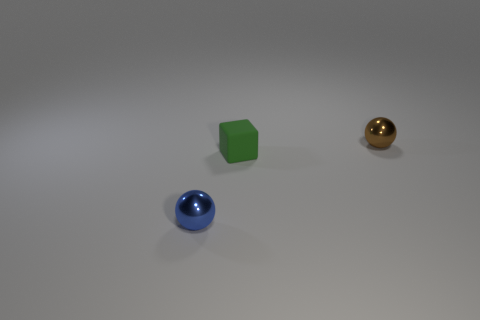If you had to associate an emotion with this image, what would it be? The image exudes a sense of calm and simplicity. The minimalistic arrangement and the clean background could evoke feelings of serenity and order. 